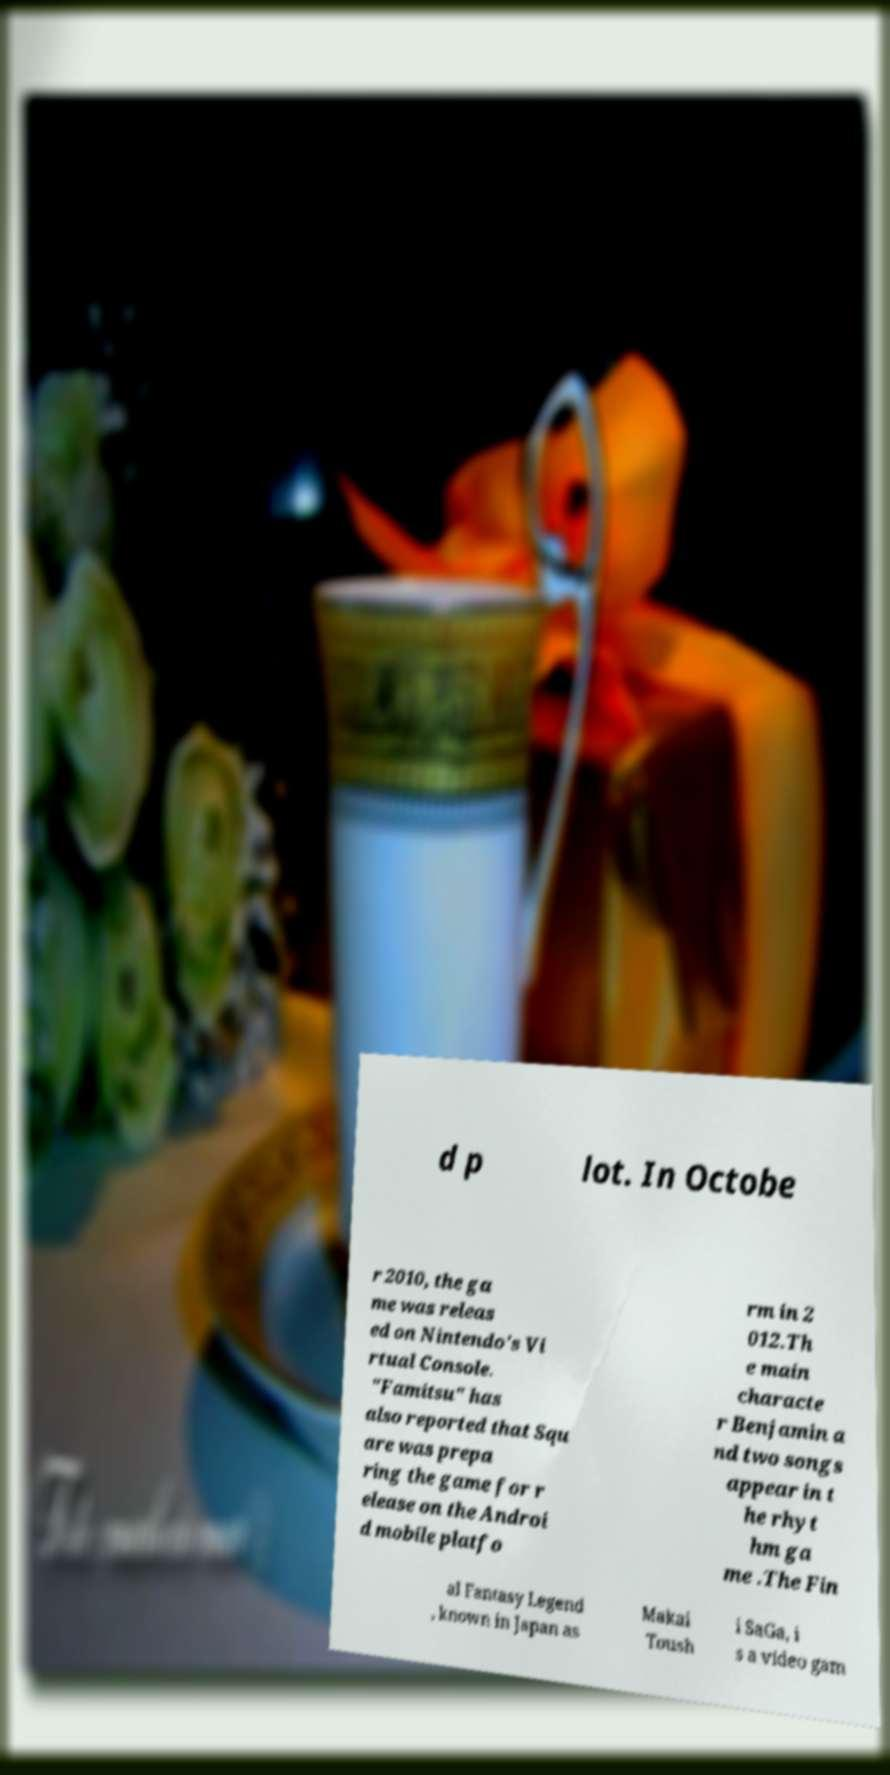Please identify and transcribe the text found in this image. d p lot. In Octobe r 2010, the ga me was releas ed on Nintendo's Vi rtual Console. "Famitsu" has also reported that Squ are was prepa ring the game for r elease on the Androi d mobile platfo rm in 2 012.Th e main characte r Benjamin a nd two songs appear in t he rhyt hm ga me .The Fin al Fantasy Legend , known in Japan as Makai Toush i SaGa, i s a video gam 